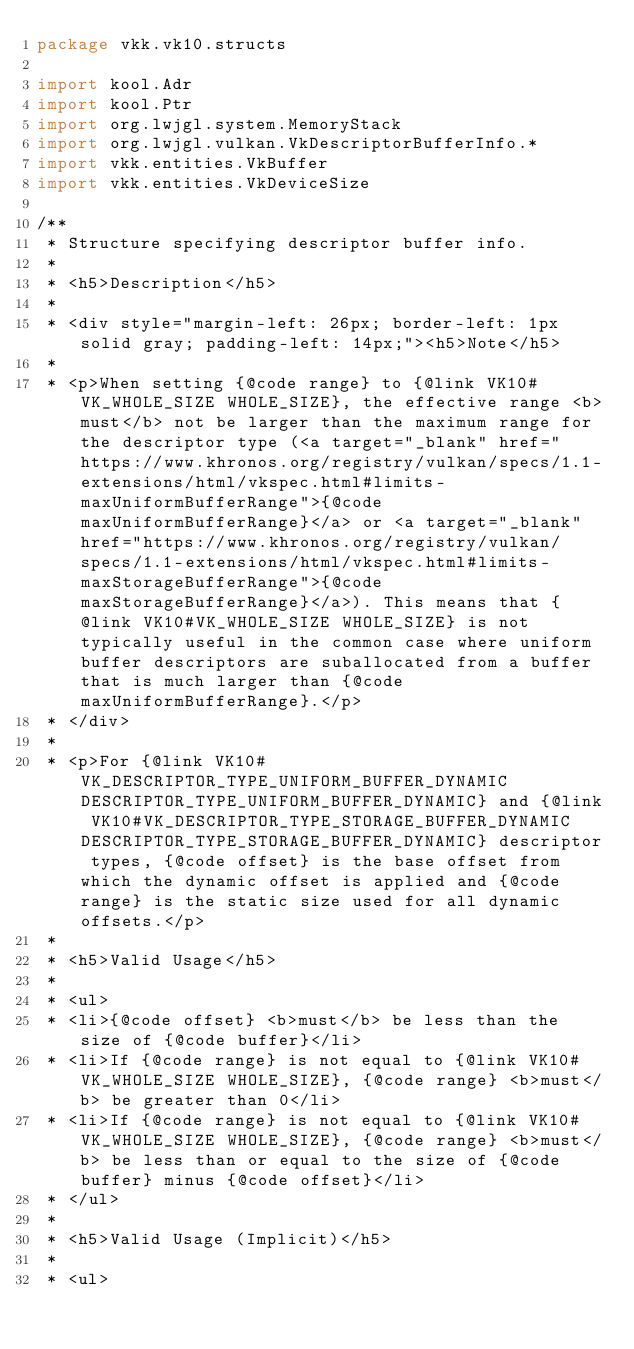<code> <loc_0><loc_0><loc_500><loc_500><_Kotlin_>package vkk.vk10.structs

import kool.Adr
import kool.Ptr
import org.lwjgl.system.MemoryStack
import org.lwjgl.vulkan.VkDescriptorBufferInfo.*
import vkk.entities.VkBuffer
import vkk.entities.VkDeviceSize

/**
 * Structure specifying descriptor buffer info.
 *
 * <h5>Description</h5>
 *
 * <div style="margin-left: 26px; border-left: 1px solid gray; padding-left: 14px;"><h5>Note</h5>
 *
 * <p>When setting {@code range} to {@link VK10#VK_WHOLE_SIZE WHOLE_SIZE}, the effective range <b>must</b> not be larger than the maximum range for the descriptor type (<a target="_blank" href="https://www.khronos.org/registry/vulkan/specs/1.1-extensions/html/vkspec.html#limits-maxUniformBufferRange">{@code maxUniformBufferRange}</a> or <a target="_blank" href="https://www.khronos.org/registry/vulkan/specs/1.1-extensions/html/vkspec.html#limits-maxStorageBufferRange">{@code maxStorageBufferRange}</a>). This means that {@link VK10#VK_WHOLE_SIZE WHOLE_SIZE} is not typically useful in the common case where uniform buffer descriptors are suballocated from a buffer that is much larger than {@code maxUniformBufferRange}.</p>
 * </div>
 *
 * <p>For {@link VK10#VK_DESCRIPTOR_TYPE_UNIFORM_BUFFER_DYNAMIC DESCRIPTOR_TYPE_UNIFORM_BUFFER_DYNAMIC} and {@link VK10#VK_DESCRIPTOR_TYPE_STORAGE_BUFFER_DYNAMIC DESCRIPTOR_TYPE_STORAGE_BUFFER_DYNAMIC} descriptor types, {@code offset} is the base offset from which the dynamic offset is applied and {@code range} is the static size used for all dynamic offsets.</p>
 *
 * <h5>Valid Usage</h5>
 *
 * <ul>
 * <li>{@code offset} <b>must</b> be less than the size of {@code buffer}</li>
 * <li>If {@code range} is not equal to {@link VK10#VK_WHOLE_SIZE WHOLE_SIZE}, {@code range} <b>must</b> be greater than 0</li>
 * <li>If {@code range} is not equal to {@link VK10#VK_WHOLE_SIZE WHOLE_SIZE}, {@code range} <b>must</b> be less than or equal to the size of {@code buffer} minus {@code offset}</li>
 * </ul>
 *
 * <h5>Valid Usage (Implicit)</h5>
 *
 * <ul></code> 